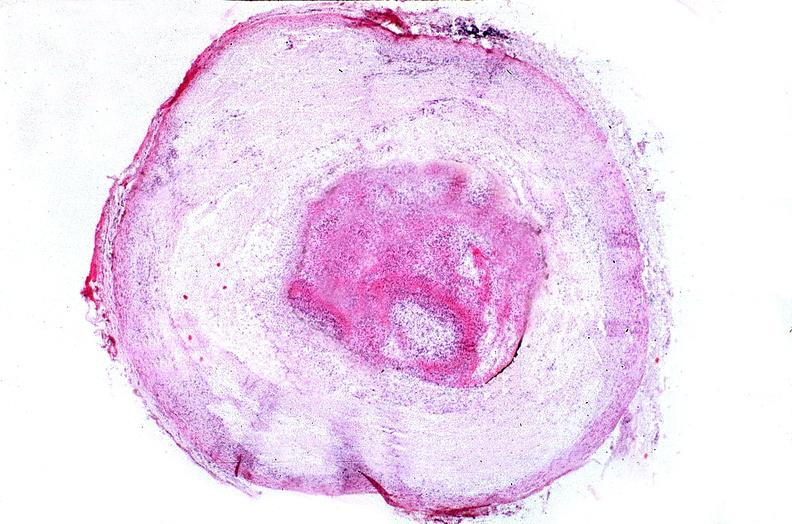does this image show coronary artery with atherosclerosis and thrombotic occlusion?
Answer the question using a single word or phrase. Yes 